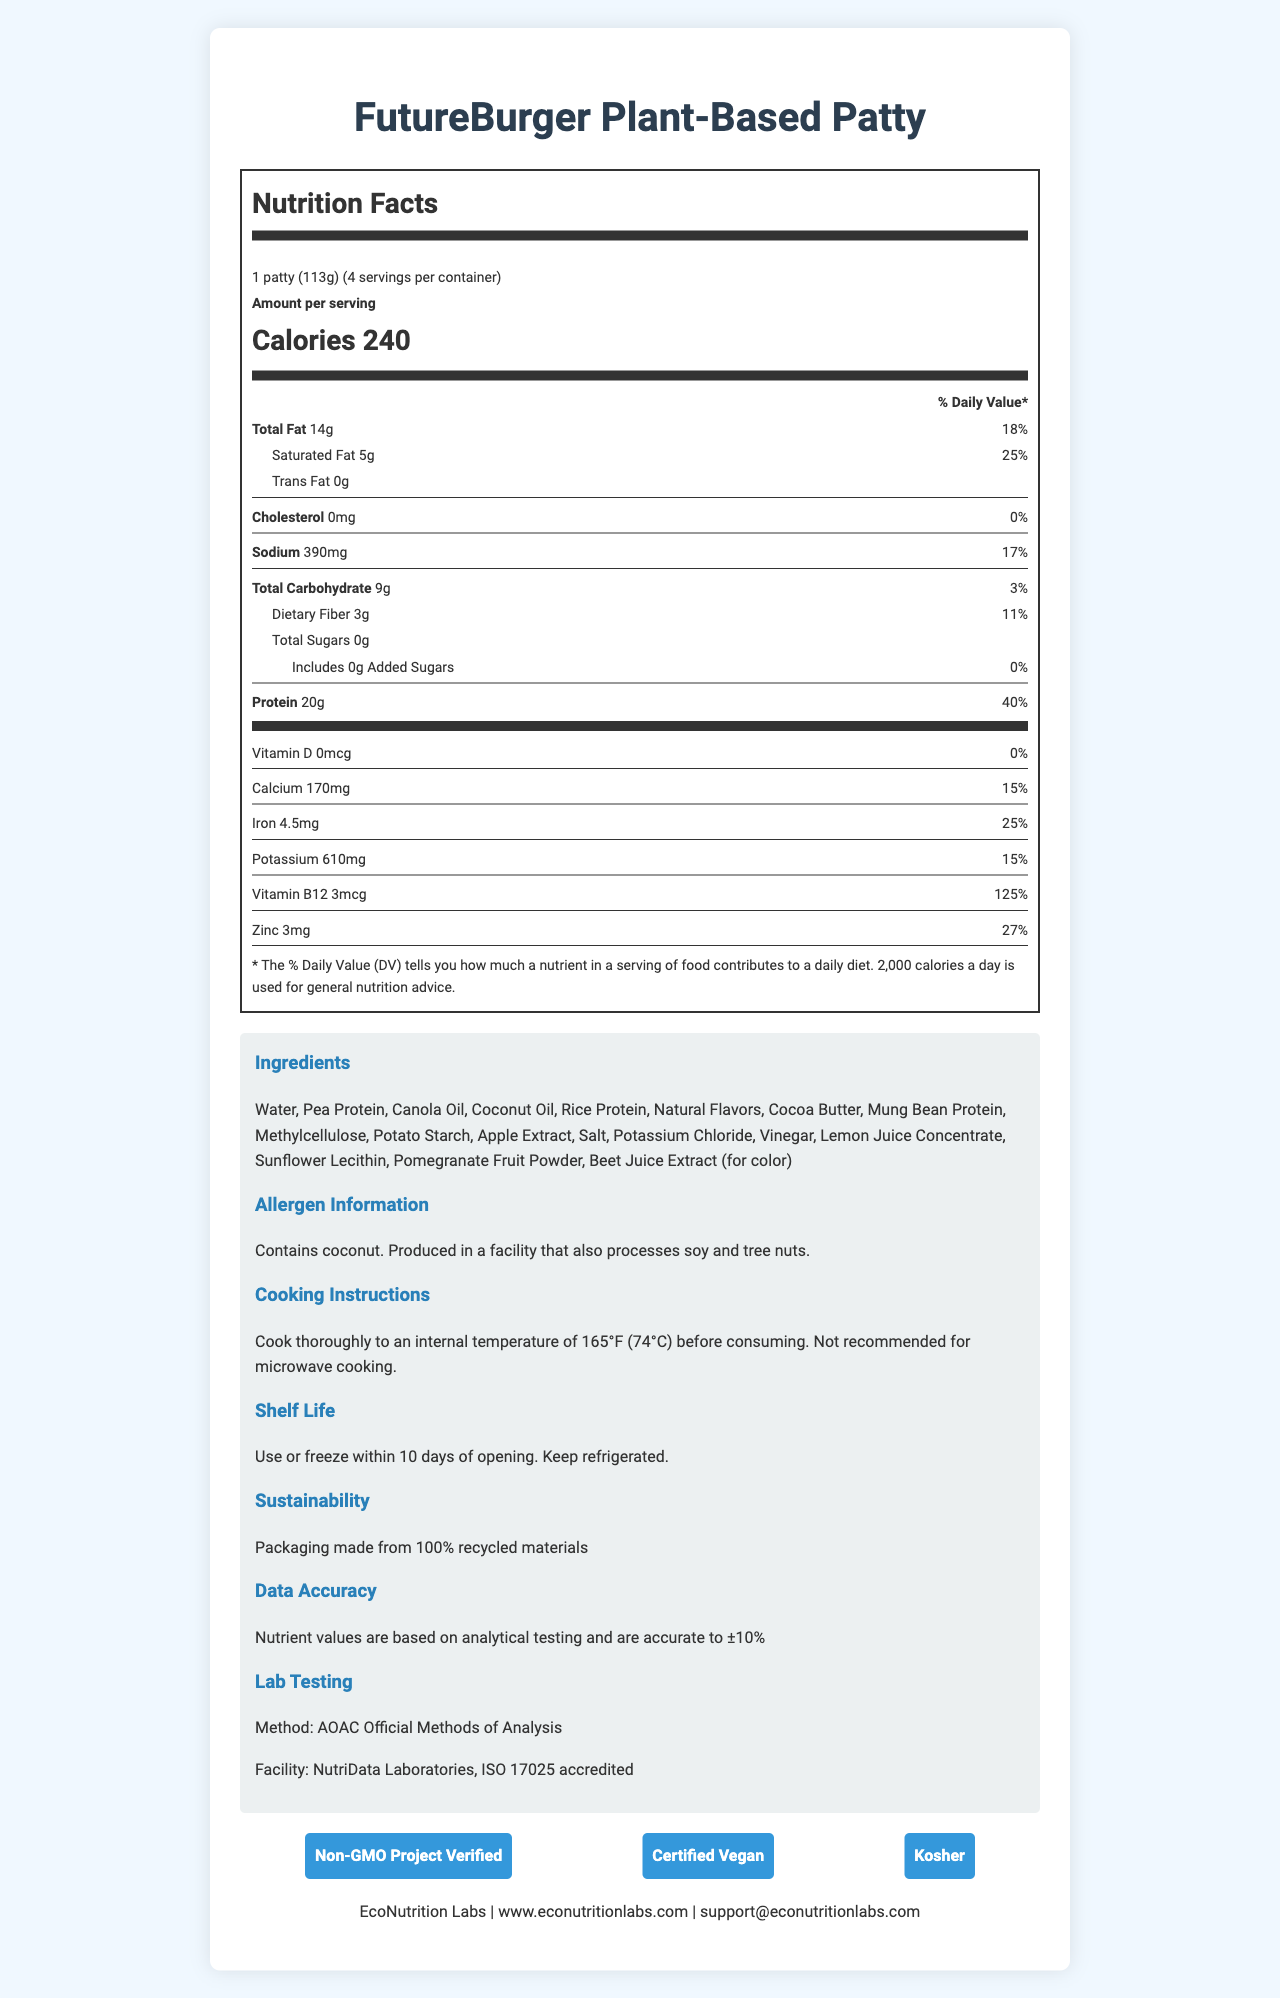what is the product name? The product name is prominently displayed at the top of the document.
Answer: FutureBurger Plant-Based Patty how many calories are there per serving? The calories per serving are listed in bold in the nutrition facts section.
Answer: 240 what is the serving size? The serving size is mentioned at the beginning of the nutrition information.
Answer: 1 patty (113g) is there any cholesterol in the patty? There is 0 mg of cholesterol mentioned in the nutrition facts.
Answer: No how much total fat is there per serving? The amount of total fat per serving is listed under the "Total Fat" section.
Answer: 14g what percentage of the daily value is the saturated fat? Saturated fat is listed as 5g, which is 25% of the daily value.
Answer: 25% is the FutureBurger certified vegan? Yes or No? The certification section indicates that it is "Certified Vegan".
Answer: Yes which of the following nutrients has the highest % daily value? A. Calcium B. Iron C. Vitamin B12 D. Protein Vitamin B12 has a daily value percentage of 125% which is the highest among the listed nutrients.
Answer: C. Vitamin B12 what is not recommended for cooking the FutureBurger? A. Grilling B. Microwaving C. Baking D. Pan-frying The cooking instructions specifically mention that microwave cooking is not recommended.
Answer: B. Microwaving how many servings are there per container? The number of servings per container is mentioned at the beginning of the nutrition information.
Answer: 4 what ingredient is included for color? Beet Juice Extract is listed among the ingredients with a note saying it is for color.
Answer: Beet Juice Extract is the sodium content more or less than 20% of the daily value? The sodium content is 17% of the daily value.
Answer: Less how should the FutureBurger be stored after opening? The shelf-life and storage instructions provide this information.
Answer: Use or freeze within 10 days and keep refrigerated what type of materials is the packaging made from? The sustainability information states that the packaging is made from 100% recycled materials.
Answer: 100% recycled materials summarize the main information provided in the document The document is a comprehensive overview of the FutureBurger Plant-Based Patty, including its nutritional content, ingredient list, dietary certifications, and handling instructions. It highlights the product's attributes such as being vegan, containing recycled packaging, and being verified for accuracy.
Answer: The document provides detailed nutritional information, ingredients, allergen information, certifications, sustainability details, cooking instructions, and storage guidelines for the FutureBurger Plant-Based Patty. It also includes company contact information and states the accuracy and testing methods used for nutritional data. what is the specific method used for lab testing? The lab testing section states that the AOAC Official Methods of Analysis was used.
Answer: AOAC Official Methods of Analysis who is the manufacturer of FutureBurger? The company information section at the end of the document provides this information.
Answer: EcoNutrition Labs what is the common allergen found in the product? The allergen information specifically lists coconut as an included allergen.
Answer: Coconut what is the daily value percentage for protein? The protein content is 20g per serving, which accounts for 40% of the daily value.
Answer: 40% how much calcium is in one serving? The amount of calcium per serving is given in the nutrition facts section.
Answer: 170mg what's the email address for customer support? The company information provides this email address for contact.
Answer: support@econutritionlabs.com is there any added sugar in the product? The document states that there is 0g of added sugars in the product.
Answer: No what are the primary proteins in the ingredients? The ingredients list highlights these as primary protein sources.
Answer: Pea Protein, Rice Protein, Mung Bean Protein how is the accuracy of nutrient values reported? The data accuracy section mentions that the nutrient values are based on analytical testing and are accurate to ±10%.
Answer: Nutrient values are accurate to ±10% how many milligrams of sodium are in one serving? The nutrition facts list the sodium content as 390mg per serving.
Answer: 390mg is the product kosher? The certification section includes Kosher certification.
Answer: Yes describe one of the challenges in interpreting the daily values percentages The document does not provide exact averages of daily recommended intakes which makes it difficult to understand how the daily values percentage fits into different dietary guidelines.
Answer: Not enough information 